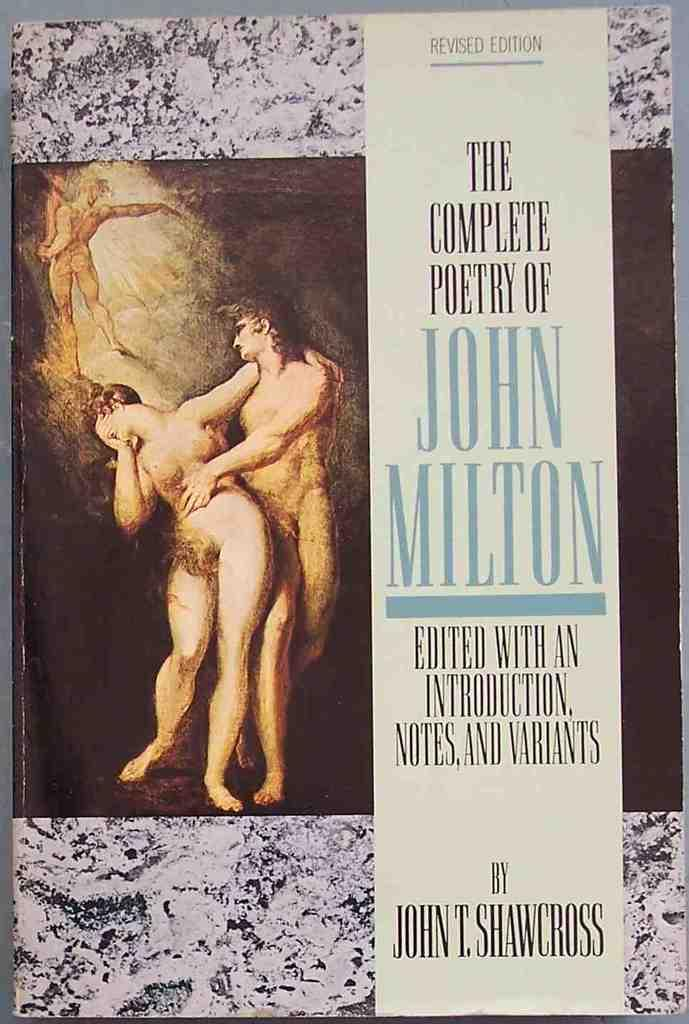<image>
Share a concise interpretation of the image provided. Nudes grace the cover of a book of poetry by John Milton. 